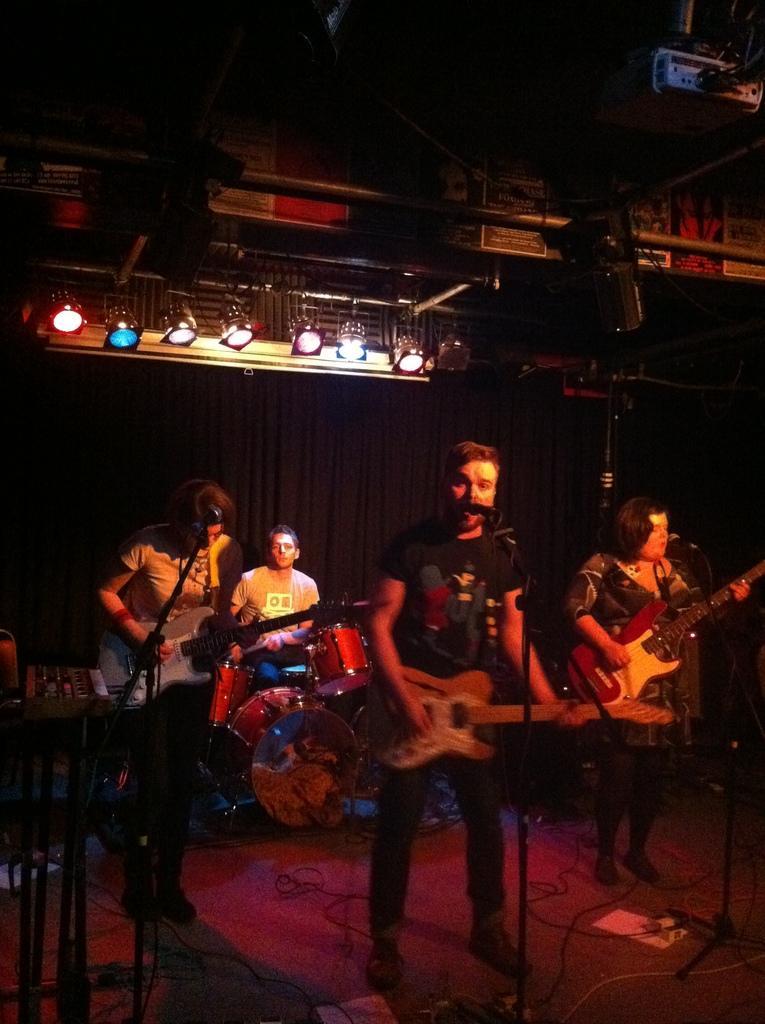Can you describe this image briefly? A rock band is performing on stage. In them three are playing guitar and the other is playing drums. There is lights on the top. 